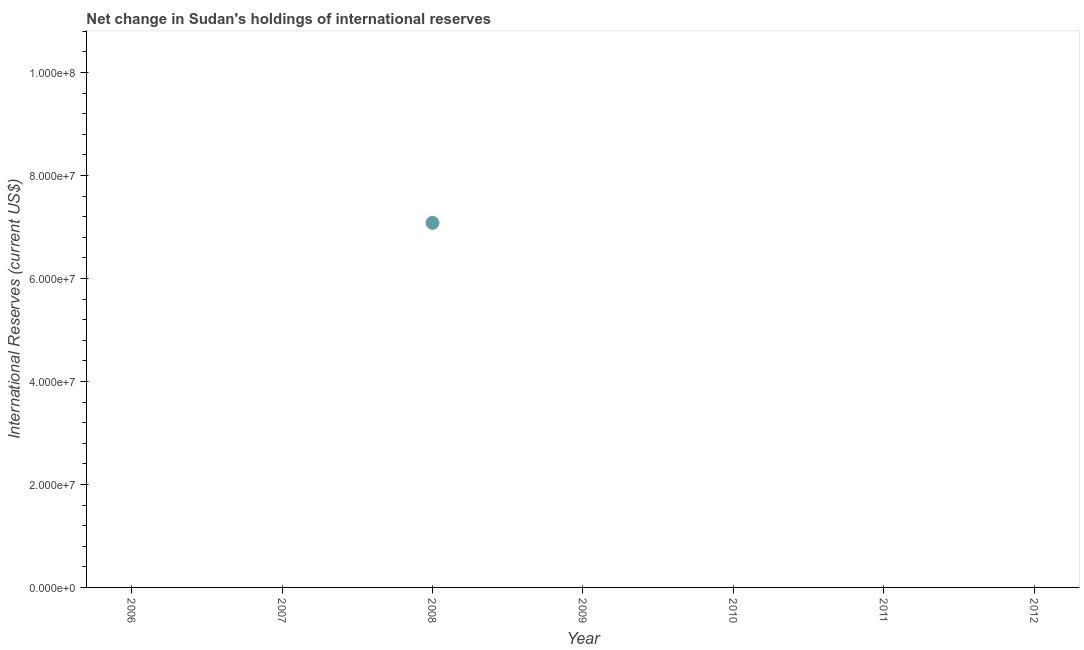What is the reserves and related items in 2006?
Ensure brevity in your answer.  0. Across all years, what is the maximum reserves and related items?
Ensure brevity in your answer.  7.08e+07. Across all years, what is the minimum reserves and related items?
Your response must be concise. 0. What is the sum of the reserves and related items?
Ensure brevity in your answer.  7.08e+07. What is the average reserves and related items per year?
Make the answer very short. 1.01e+07. What is the difference between the highest and the lowest reserves and related items?
Provide a succinct answer. 7.08e+07. Does the reserves and related items monotonically increase over the years?
Offer a terse response. No. How many dotlines are there?
Make the answer very short. 1. How many years are there in the graph?
Provide a short and direct response. 7. What is the difference between two consecutive major ticks on the Y-axis?
Provide a short and direct response. 2.00e+07. Are the values on the major ticks of Y-axis written in scientific E-notation?
Your answer should be very brief. Yes. Does the graph contain any zero values?
Make the answer very short. Yes. Does the graph contain grids?
Provide a short and direct response. No. What is the title of the graph?
Make the answer very short. Net change in Sudan's holdings of international reserves. What is the label or title of the X-axis?
Provide a short and direct response. Year. What is the label or title of the Y-axis?
Provide a succinct answer. International Reserves (current US$). What is the International Reserves (current US$) in 2006?
Ensure brevity in your answer.  0. What is the International Reserves (current US$) in 2008?
Make the answer very short. 7.08e+07. What is the International Reserves (current US$) in 2012?
Offer a very short reply. 0. 